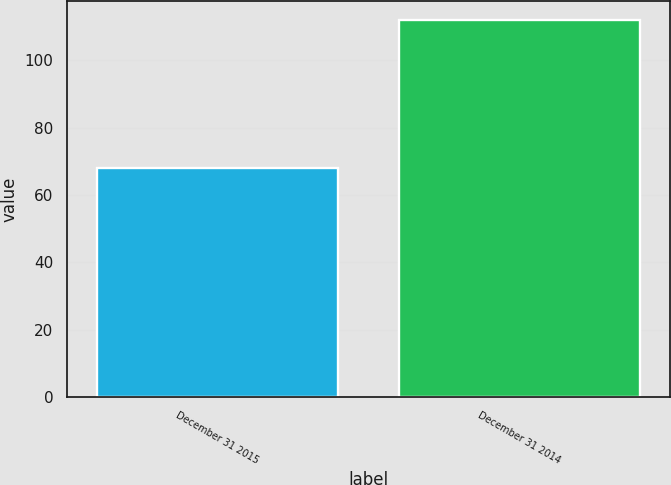Convert chart. <chart><loc_0><loc_0><loc_500><loc_500><bar_chart><fcel>December 31 2015<fcel>December 31 2014<nl><fcel>68<fcel>112<nl></chart> 